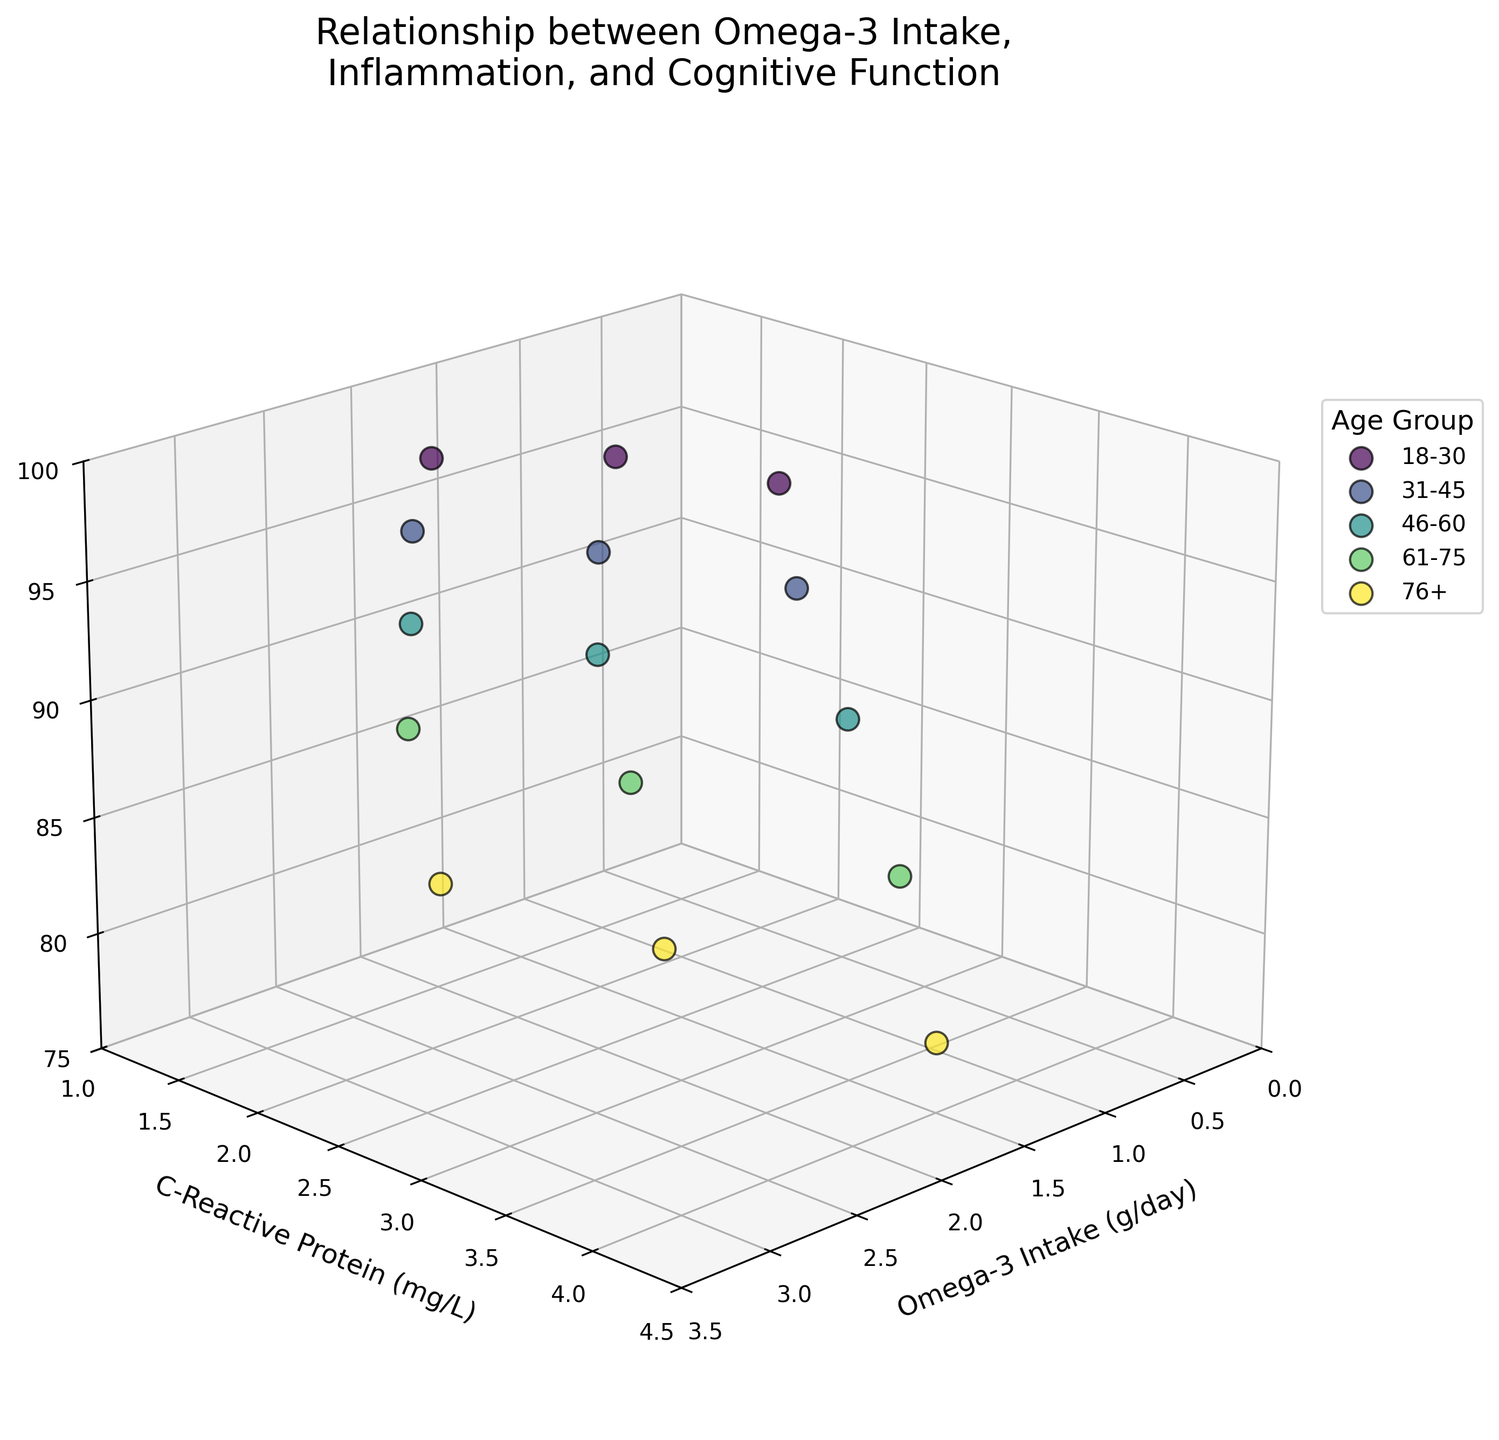What are the axes labels in the 3D plot? The axes labels in the 3D plot can be seen directly. The x-axis is labeled as "Omega-3 Intake (g/day)", the y-axis is labeled as "C-Reactive Protein (mg/L)", and the z-axis is labeled as "Cognitive Function Score".
Answer: X-axis: Omega-3 Intake (g/day), Y-axis: C-Reactive Protein (mg/L), Z-axis: Cognitive Function Score What is the title of the 3D plot? The title of the 3D plot is clearly stated at the top. It reads "Relationship between Omega-3 Intake, Inflammation, and Cognitive Function".
Answer: Relationship between Omega-3 Intake, Inflammation, and Cognitive Function Which age group tends to have the highest Cognitive Function Score? By observing the positions of the scatter points along the z-axis, the "18-30" age group appears to have the highest Cognitive Function Scores, with values around 95-98.
Answer: 18-30 How does C-Reactive Protein levels vary with Omega-3 Intake for the age group 61-75? For the age group 61-75, the plot shows that as Omega-3 Intake increases from 1.2 to 2.8 g/day, C-Reactive Protein levels decrease from 3.5 to 2.2 mg/L.
Answer: Decrease What is the Cognitive Function Score for a 76+ age group individual with an Omega-3 intake of 2.3 g/day? By locating the point representing the 76+ age group with an Omega-3 intake of 2.3 g/day, we find that the corresponding Cognitive Function Score is 82.
Answer: 82 Compare the C-Reactive Protein levels between the 18-30 and 31-45 age groups at a similar Omega-3 Intake of around 2 g/day. The plot shows that at an Omega-3 intake of around 2 g/day, the 18-30 age group has a C-Reactive Protein level of approximately 1.5 mg/L, while the 31-45 age group has a level of approximately 1.7 mg/L. Therefore, the 18-30 age group's C-Reactive Protein level is slightly lower.
Answer: 18-30: ~1.5 mg/L, 31-45: ~1.7 mg/L What is the relationship between Omega-3 Intake and Cognitive Function Scores across different age groups? From the 3D plot, we can observe a general trend where higher Omega-3 Intake usually corresponds to higher Cognitive Function Scores across all age groups, although the exact relationship can vary slightly among different groups.
Answer: Positive correlation How do the Cognitive Function Scores compare between age groups with the lowest Omega-3 Intake? By examining the lowest Omega-3 Intake values for each age group, the 18-30 age group has a Cognitive Function Score of 95, the 31-45 age group has 92, the 46-60 age group has 88, the 61-75 age group has 83, and the 76+ age group has 78. The scores decrease with increasing age.
Answer: Decrease with age At around 1.5 mg/L of C-Reactive Protein, which age group has the highest Cognitive Function Score? For C-Reactive Protein levels around 1.5 mg/L, the 18-30 age group has the highest Cognitive Function Score of 98, compared to other age groups.
Answer: 18-30 